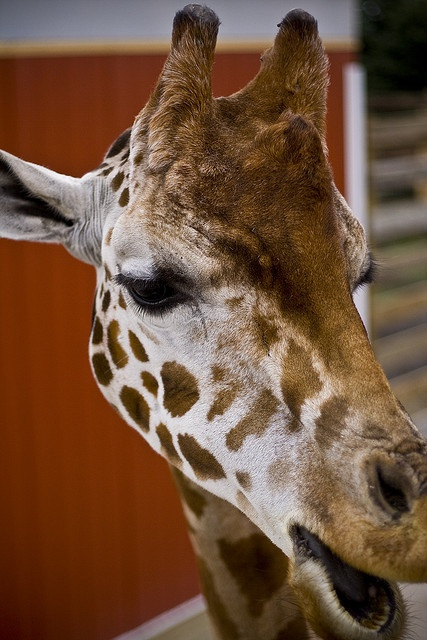Describe the objects in this image and their specific colors. I can see a giraffe in gray, maroon, black, and darkgray tones in this image. 